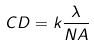<formula> <loc_0><loc_0><loc_500><loc_500>C D = k \frac { \lambda } { N A }</formula> 